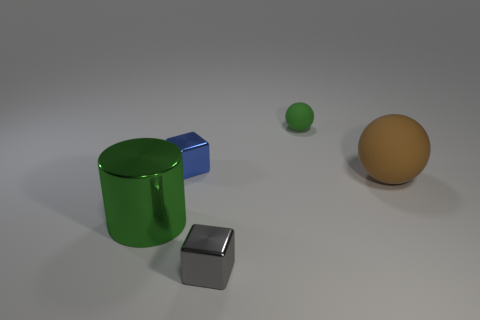What materials are the objects made of? The objects appear to include a green rubber ball, a blue metallic cube, a grey metallic cube, and an orange ball which could be made of a matte plastic or rubber. 